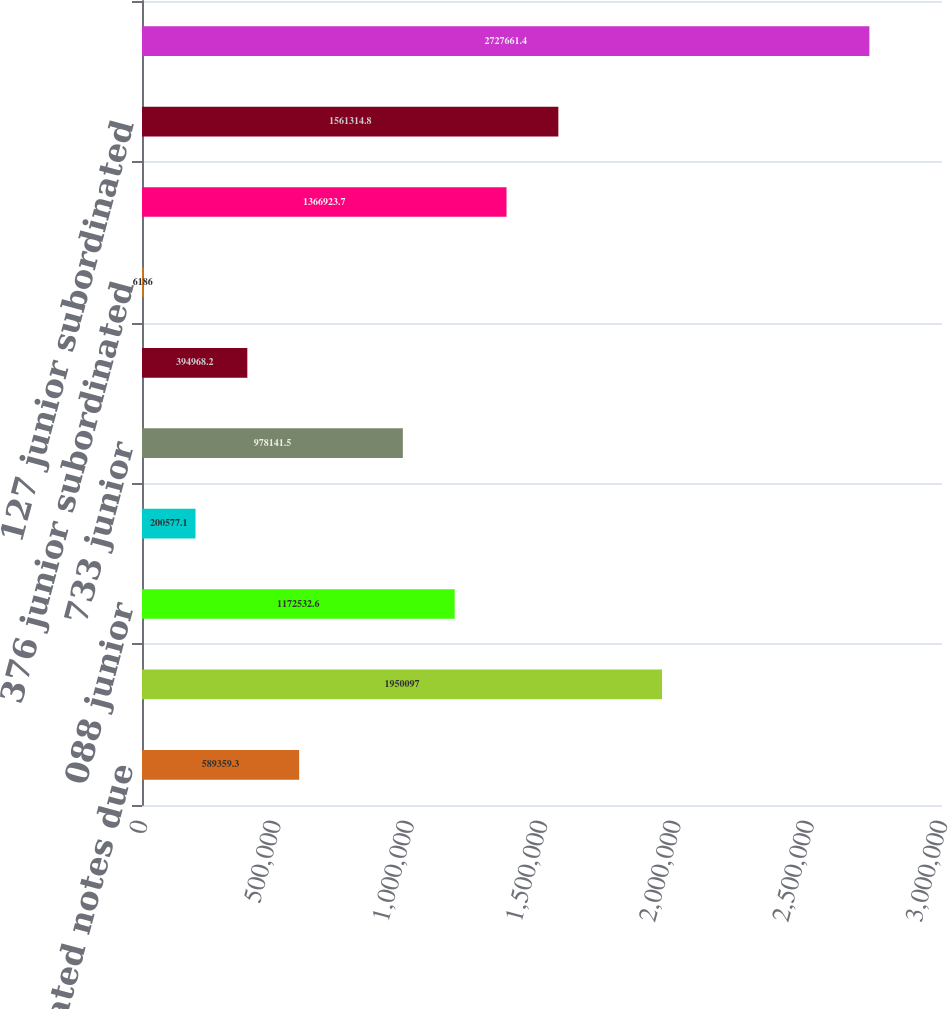Convert chart to OTSL. <chart><loc_0><loc_0><loc_500><loc_500><bar_chart><fcel>621 subordinated notes due<fcel>098 junior<fcel>088 junior<fcel>854 junior subordinated<fcel>733 junior<fcel>345 junior subordinated<fcel>376 junior subordinated<fcel>123 junior subordinated<fcel>127 junior subordinated<fcel>669 junior subordinated<nl><fcel>589359<fcel>1.9501e+06<fcel>1.17253e+06<fcel>200577<fcel>978142<fcel>394968<fcel>6186<fcel>1.36692e+06<fcel>1.56131e+06<fcel>2.72766e+06<nl></chart> 